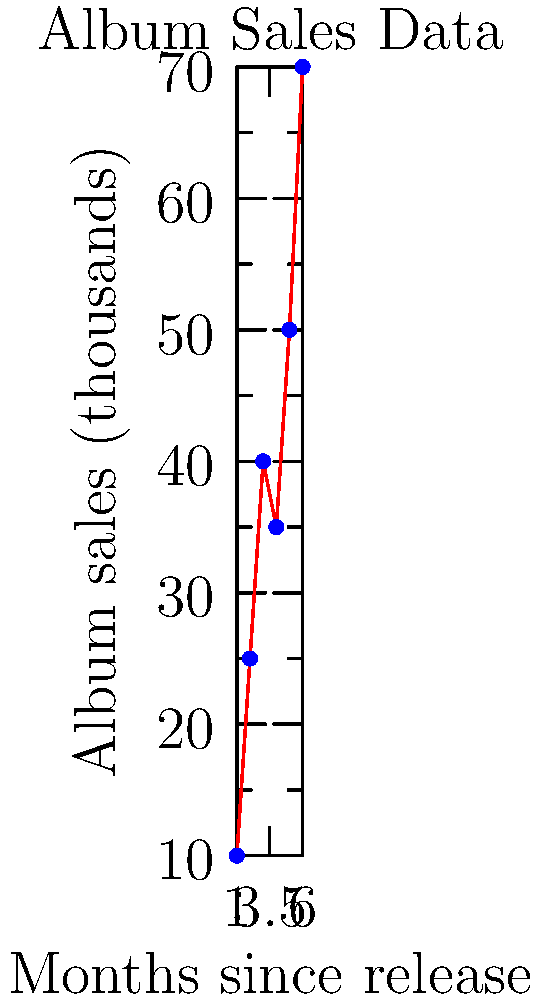Your latest album's sales data over the first 6 months since its release is plotted on the coordinate plane above. If this trend continues linearly, approximately how many album sales (in thousands) would you expect in the 9th month after release? To solve this problem, we'll follow these steps:

1. Observe the trend in the given data:
   The sales are generally increasing, with a slight dip in the 4th month.

2. Estimate the linear trend:
   We can approximate this as a linear trend, focusing on the overall increase.

3. Calculate the rate of change:
   Let's use the first and last points to estimate the average rate of increase.
   $\text{Rate} = \frac{\text{Change in y}}{\text{Change in x}} = \frac{70 - 10}{6 - 1} = \frac{60}{5} = 12$ thousand/month

4. Use the point-slope form of a line:
   $y - y_1 = m(x - x_1)$, where $m$ is the rate of change
   Using the last point (6, 70):
   $y - 70 = 12(x - 6)$

5. Plug in $x = 9$ (9th month) to find $y$:
   $y - 70 = 12(9 - 6)$
   $y - 70 = 12(3) = 36$
   $y = 70 + 36 = 106$

Therefore, if the trend continues linearly, you would expect approximately 106 thousand album sales in the 9th month after release.
Answer: 106 thousand 